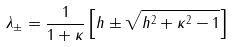Convert formula to latex. <formula><loc_0><loc_0><loc_500><loc_500>\lambda _ { \pm } = \frac { 1 } { 1 + \kappa } \left [ h \pm \sqrt { h ^ { 2 } + \kappa ^ { 2 } - 1 } \right ]</formula> 